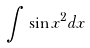Convert formula to latex. <formula><loc_0><loc_0><loc_500><loc_500>\int \sin x ^ { 2 } d x</formula> 